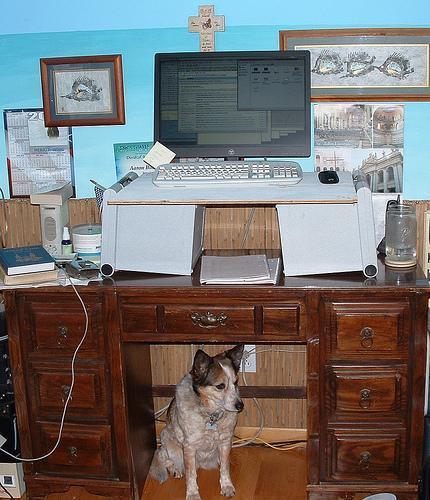How many desks are there?
Give a very brief answer. 1. 